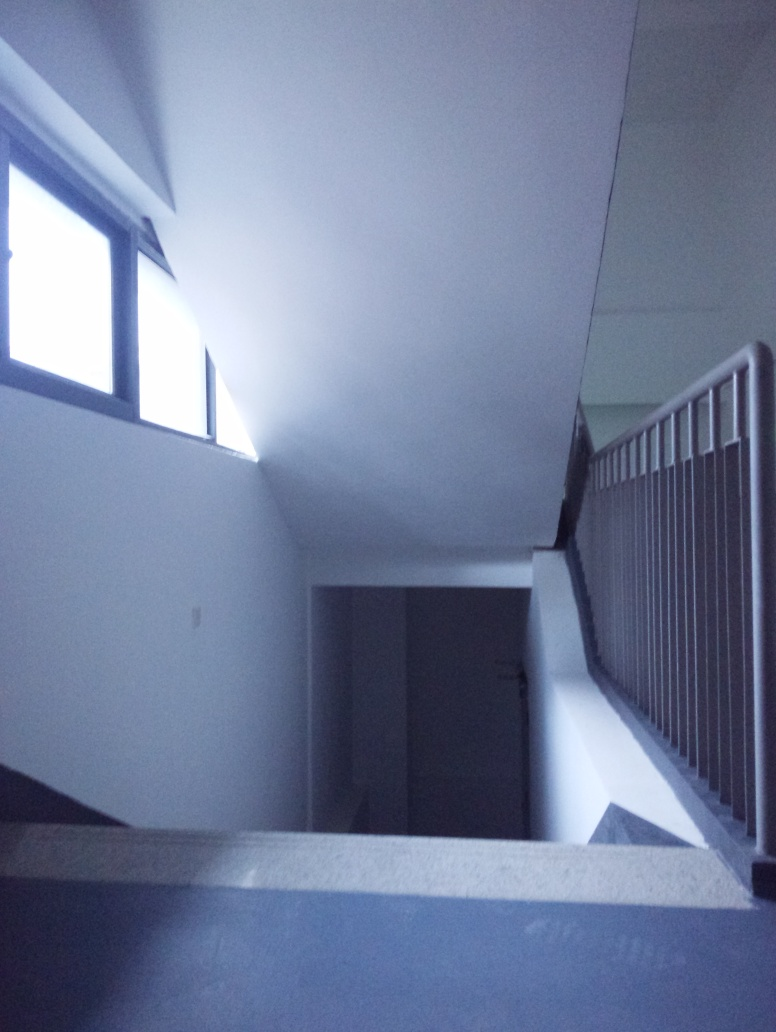What time of day do you think it is based on the lighting in this image? Given the soft light coming through the windows, which suggests a lack of direct sunlight, it could be either morning or late afternoon. However, there are no distinct indicators such as the angle of the shadows, so we can't determine the time precisely. 